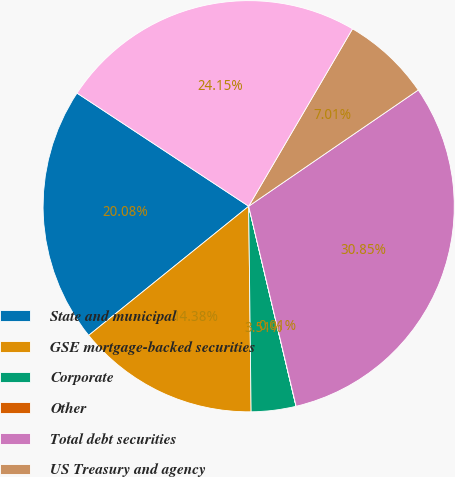<chart> <loc_0><loc_0><loc_500><loc_500><pie_chart><fcel>State and municipal<fcel>GSE mortgage-backed securities<fcel>Corporate<fcel>Other<fcel>Total debt securities<fcel>US Treasury and agency<fcel>GSE mortgage-backed and CMO<nl><fcel>20.08%<fcel>14.38%<fcel>3.51%<fcel>0.01%<fcel>30.85%<fcel>7.01%<fcel>24.15%<nl></chart> 